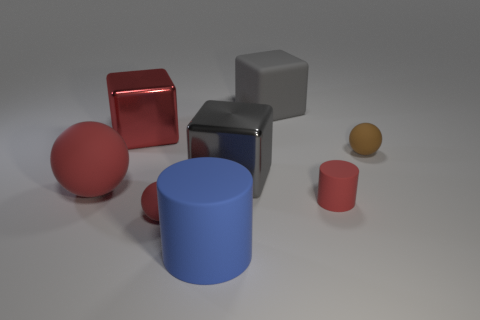Subtract all gray cubes. How many were subtracted if there are1gray cubes left? 1 Add 2 brown balls. How many objects exist? 10 Subtract all cylinders. How many objects are left? 6 Subtract 0 yellow spheres. How many objects are left? 8 Subtract all large cyan shiny cylinders. Subtract all large gray matte cubes. How many objects are left? 7 Add 4 gray matte things. How many gray matte things are left? 5 Add 1 matte cylinders. How many matte cylinders exist? 3 